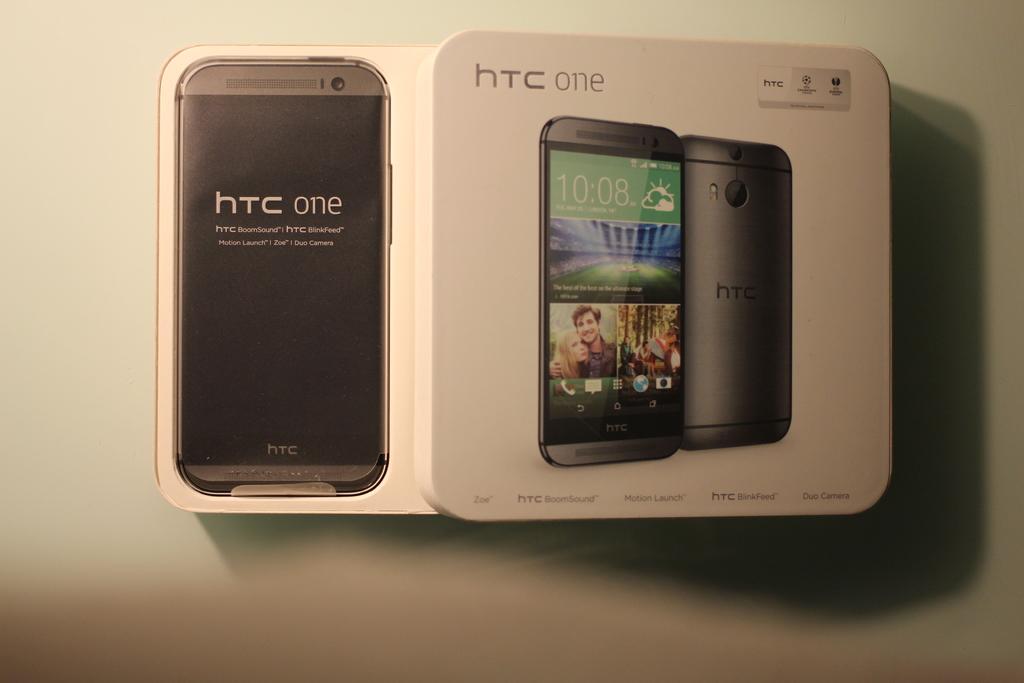What brand of phone is this?
Your response must be concise. Htc. What model of phone is this?
Your answer should be very brief. Htc one. 